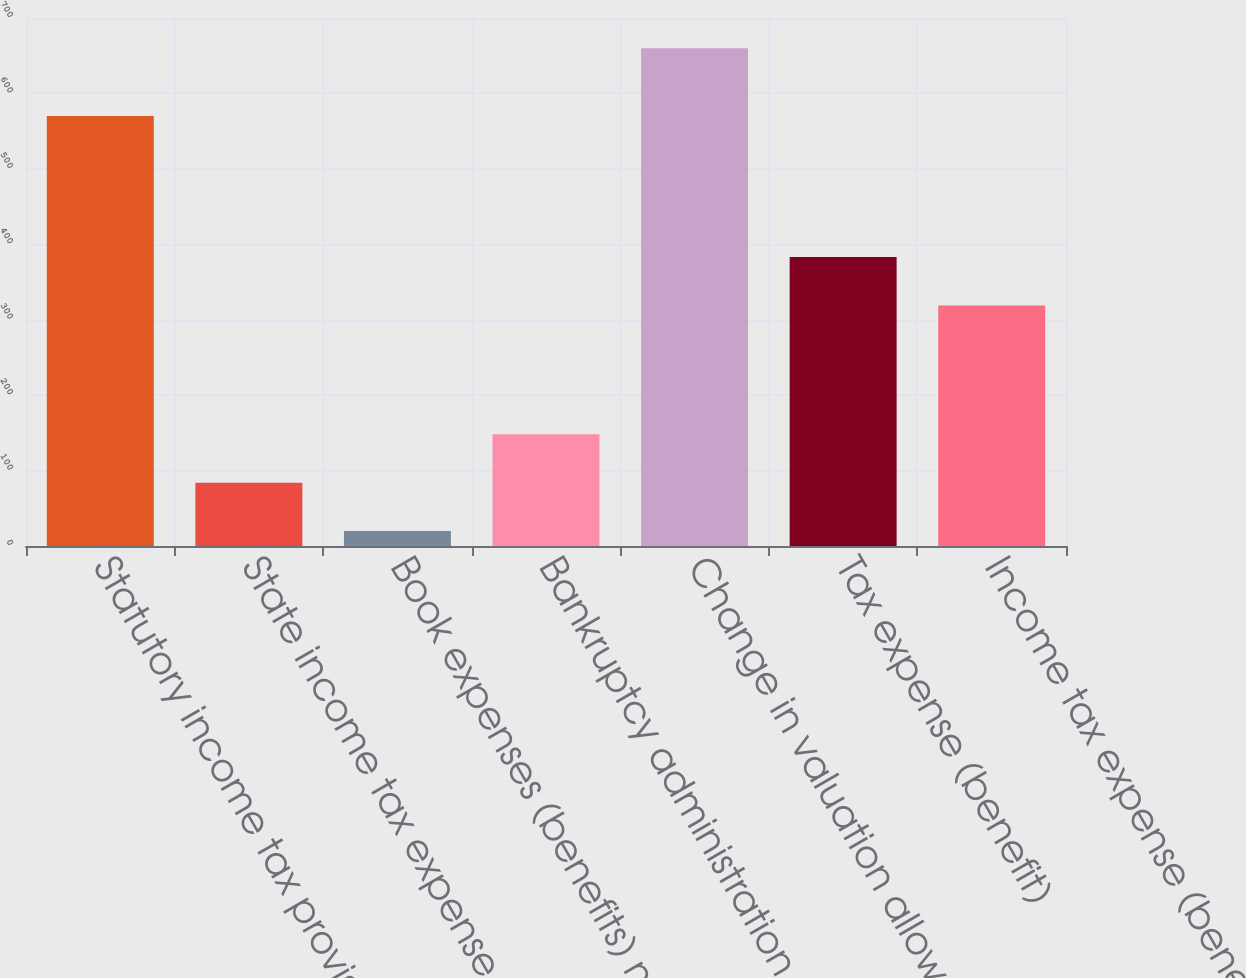<chart> <loc_0><loc_0><loc_500><loc_500><bar_chart><fcel>Statutory income tax provision<fcel>State income tax expense<fcel>Book expenses (benefits) not<fcel>Bankruptcy administration<fcel>Change in valuation allowance<fcel>Tax expense (benefit)<fcel>Income tax expense (benefit)<nl><fcel>570<fcel>84<fcel>20<fcel>148<fcel>660<fcel>383<fcel>319<nl></chart> 